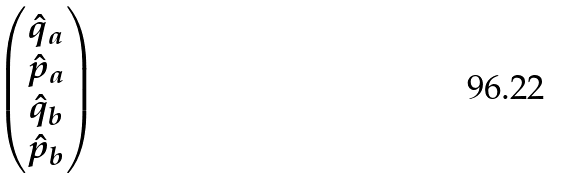<formula> <loc_0><loc_0><loc_500><loc_500>\begin{pmatrix} \hat { q } _ { a } \\ \hat { p } _ { a } \\ \hat { q } _ { b } \\ \hat { p } _ { b } \end{pmatrix}</formula> 